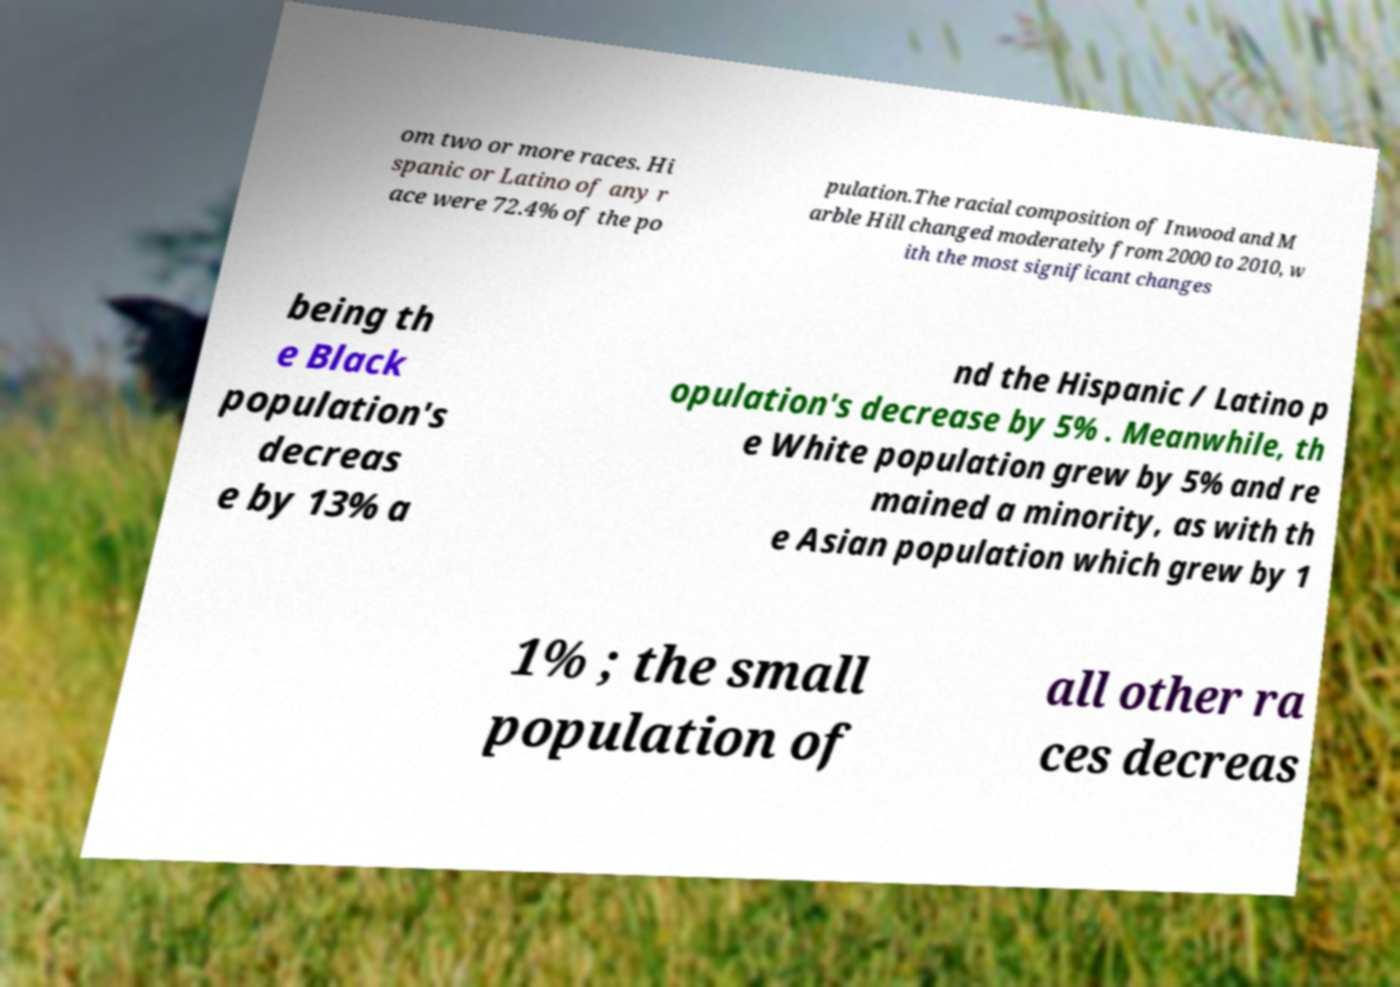Please read and relay the text visible in this image. What does it say? om two or more races. Hi spanic or Latino of any r ace were 72.4% of the po pulation.The racial composition of Inwood and M arble Hill changed moderately from 2000 to 2010, w ith the most significant changes being th e Black population's decreas e by 13% a nd the Hispanic / Latino p opulation's decrease by 5% . Meanwhile, th e White population grew by 5% and re mained a minority, as with th e Asian population which grew by 1 1% ; the small population of all other ra ces decreas 